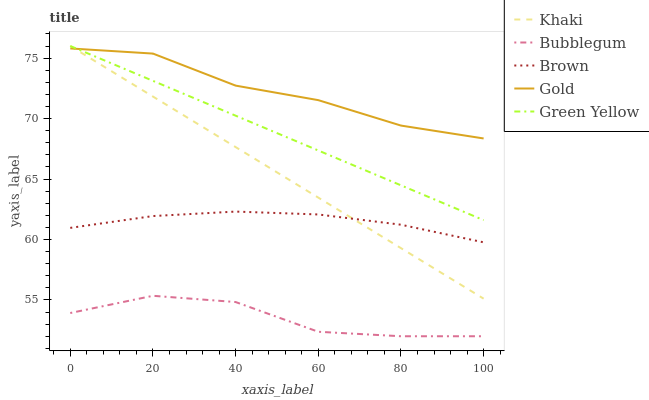Does Bubblegum have the minimum area under the curve?
Answer yes or no. Yes. Does Gold have the maximum area under the curve?
Answer yes or no. Yes. Does Green Yellow have the minimum area under the curve?
Answer yes or no. No. Does Green Yellow have the maximum area under the curve?
Answer yes or no. No. Is Khaki the smoothest?
Answer yes or no. Yes. Is Bubblegum the roughest?
Answer yes or no. Yes. Is Green Yellow the smoothest?
Answer yes or no. No. Is Green Yellow the roughest?
Answer yes or no. No. Does Bubblegum have the lowest value?
Answer yes or no. Yes. Does Green Yellow have the lowest value?
Answer yes or no. No. Does Khaki have the highest value?
Answer yes or no. Yes. Does Gold have the highest value?
Answer yes or no. No. Is Bubblegum less than Green Yellow?
Answer yes or no. Yes. Is Green Yellow greater than Bubblegum?
Answer yes or no. Yes. Does Khaki intersect Gold?
Answer yes or no. Yes. Is Khaki less than Gold?
Answer yes or no. No. Is Khaki greater than Gold?
Answer yes or no. No. Does Bubblegum intersect Green Yellow?
Answer yes or no. No. 